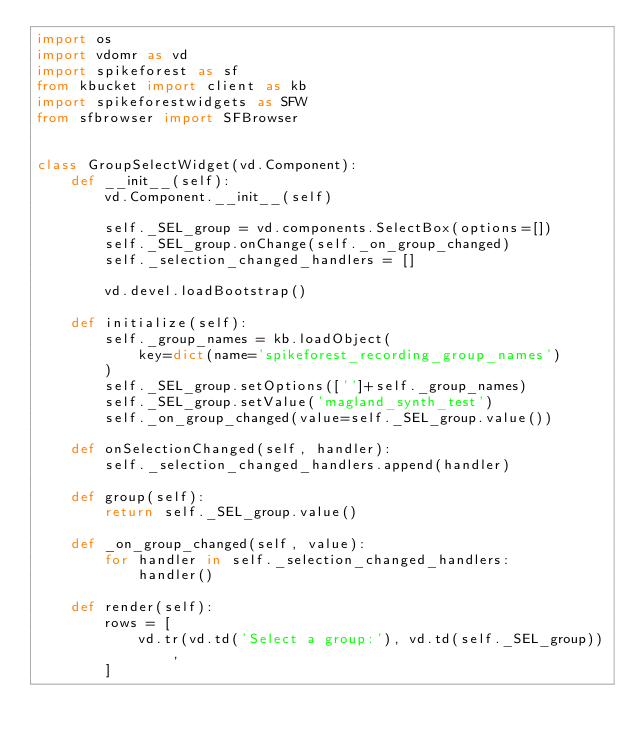<code> <loc_0><loc_0><loc_500><loc_500><_Python_>import os
import vdomr as vd
import spikeforest as sf
from kbucket import client as kb
import spikeforestwidgets as SFW
from sfbrowser import SFBrowser


class GroupSelectWidget(vd.Component):
    def __init__(self):
        vd.Component.__init__(self)

        self._SEL_group = vd.components.SelectBox(options=[])
        self._SEL_group.onChange(self._on_group_changed)
        self._selection_changed_handlers = []

        vd.devel.loadBootstrap()

    def initialize(self):
        self._group_names = kb.loadObject(
            key=dict(name='spikeforest_recording_group_names')
        )
        self._SEL_group.setOptions(['']+self._group_names)
        self._SEL_group.setValue('magland_synth_test')
        self._on_group_changed(value=self._SEL_group.value())

    def onSelectionChanged(self, handler):
        self._selection_changed_handlers.append(handler)

    def group(self):
        return self._SEL_group.value()

    def _on_group_changed(self, value):
        for handler in self._selection_changed_handlers:
            handler()

    def render(self):
        rows = [
            vd.tr(vd.td('Select a group:'), vd.td(self._SEL_group)),
        ]</code> 